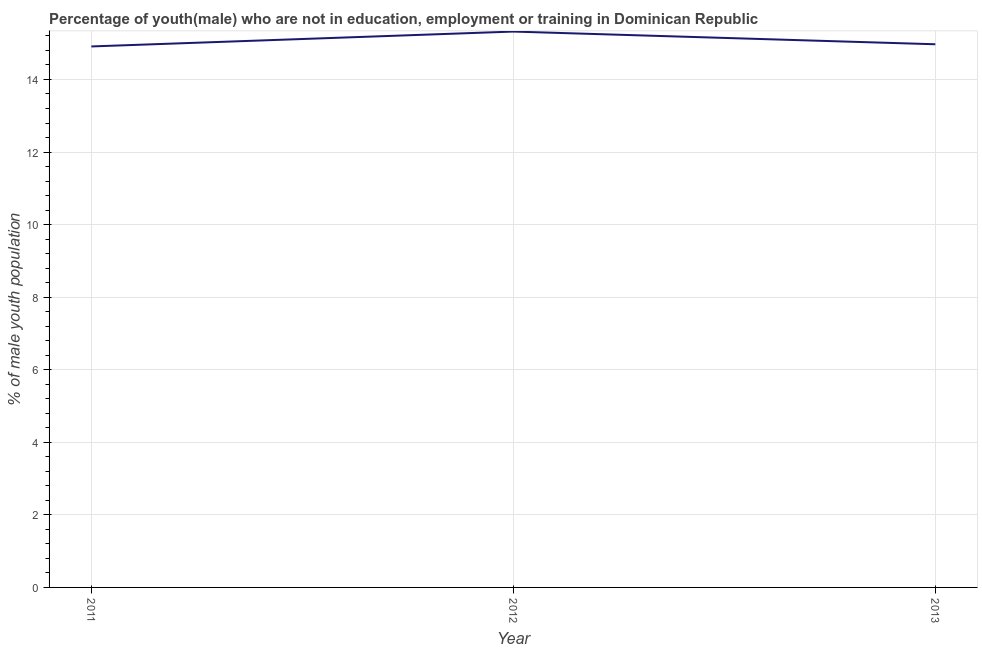What is the unemployed male youth population in 2011?
Your response must be concise. 14.91. Across all years, what is the maximum unemployed male youth population?
Your answer should be compact. 15.32. Across all years, what is the minimum unemployed male youth population?
Make the answer very short. 14.91. In which year was the unemployed male youth population maximum?
Offer a very short reply. 2012. What is the sum of the unemployed male youth population?
Your answer should be very brief. 45.2. What is the difference between the unemployed male youth population in 2011 and 2013?
Provide a succinct answer. -0.06. What is the average unemployed male youth population per year?
Keep it short and to the point. 15.07. What is the median unemployed male youth population?
Your response must be concise. 14.97. Do a majority of the years between 2011 and 2012 (inclusive) have unemployed male youth population greater than 14.8 %?
Offer a terse response. Yes. What is the ratio of the unemployed male youth population in 2011 to that in 2012?
Provide a succinct answer. 0.97. Is the difference between the unemployed male youth population in 2011 and 2012 greater than the difference between any two years?
Give a very brief answer. Yes. What is the difference between the highest and the second highest unemployed male youth population?
Offer a terse response. 0.35. What is the difference between the highest and the lowest unemployed male youth population?
Keep it short and to the point. 0.41. Does the unemployed male youth population monotonically increase over the years?
Keep it short and to the point. No. How many years are there in the graph?
Keep it short and to the point. 3. Does the graph contain any zero values?
Your answer should be very brief. No. What is the title of the graph?
Give a very brief answer. Percentage of youth(male) who are not in education, employment or training in Dominican Republic. What is the label or title of the Y-axis?
Keep it short and to the point. % of male youth population. What is the % of male youth population of 2011?
Your answer should be very brief. 14.91. What is the % of male youth population of 2012?
Offer a terse response. 15.32. What is the % of male youth population of 2013?
Your response must be concise. 14.97. What is the difference between the % of male youth population in 2011 and 2012?
Provide a short and direct response. -0.41. What is the difference between the % of male youth population in 2011 and 2013?
Offer a very short reply. -0.06. What is the difference between the % of male youth population in 2012 and 2013?
Your response must be concise. 0.35. What is the ratio of the % of male youth population in 2011 to that in 2013?
Give a very brief answer. 1. What is the ratio of the % of male youth population in 2012 to that in 2013?
Give a very brief answer. 1.02. 